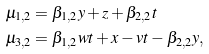Convert formula to latex. <formula><loc_0><loc_0><loc_500><loc_500>\mu _ { 1 , 2 } & = \beta _ { 1 , 2 } y + z + \beta _ { 2 , 2 } t \\ \mu _ { 3 , 2 } & = \beta _ { 1 , 2 } w t + x - v t - \beta _ { 2 , 2 } y ,</formula> 